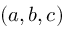Convert formula to latex. <formula><loc_0><loc_0><loc_500><loc_500>( a , b , c )</formula> 